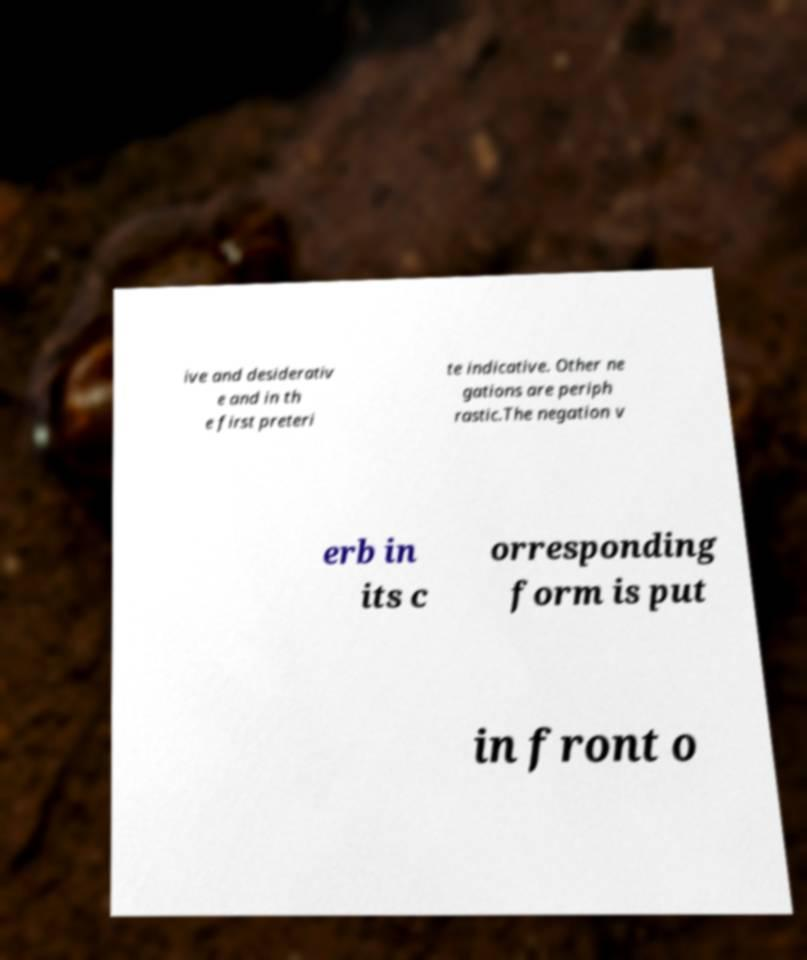For documentation purposes, I need the text within this image transcribed. Could you provide that? ive and desiderativ e and in th e first preteri te indicative. Other ne gations are periph rastic.The negation v erb in its c orresponding form is put in front o 